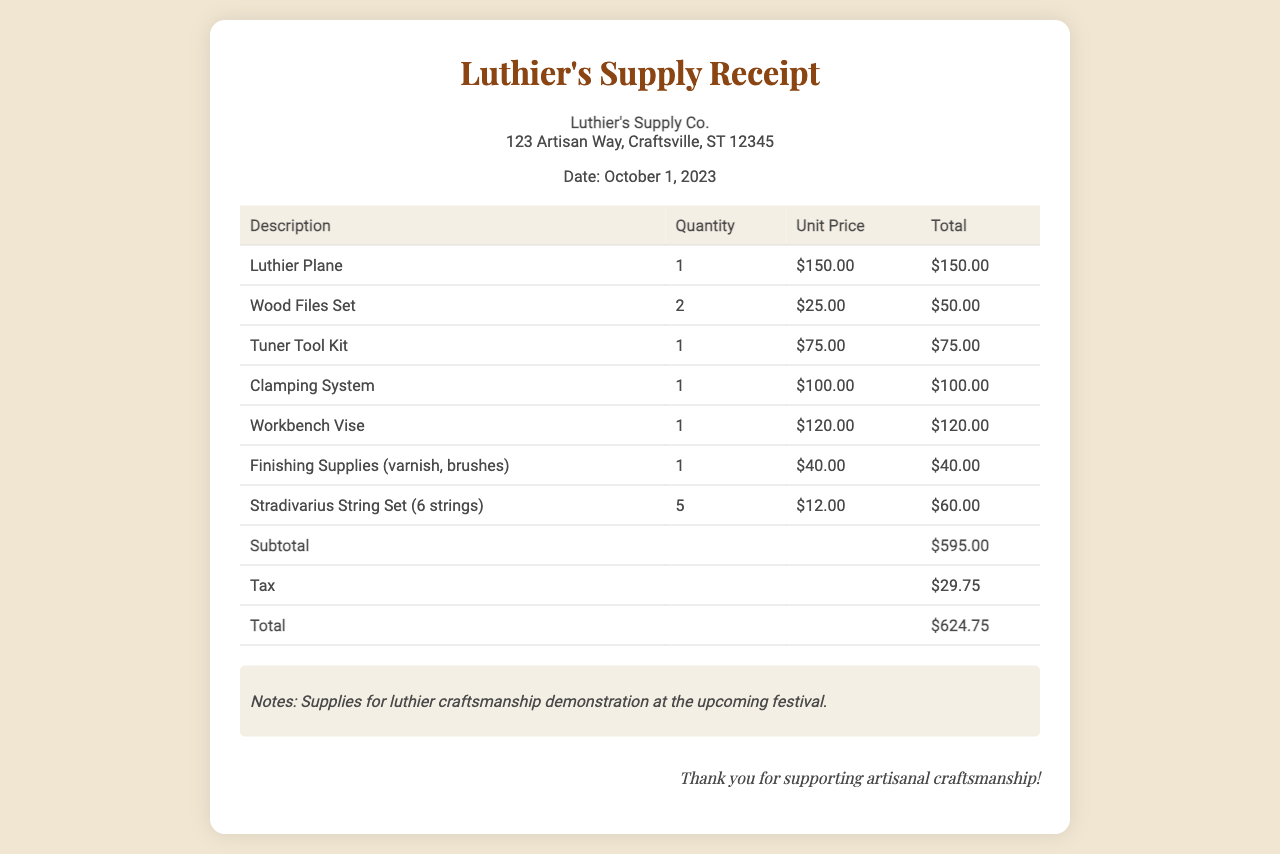What is the date of the receipt? The date listed on the receipt is October 1, 2023, which indicates when the supplies were purchased.
Answer: October 1, 2023 Who is the vendor? The vendor information in the document provides the name of the supplier of the tools, which is Luthier's Supply Co.
Answer: Luthier's Supply Co What is the total amount spent? The total amount is summarily calculated at the end of the receipt and includes subtotal and tax, which is $624.75.
Answer: $624.75 How many Stradivarius String Sets were purchased? The receipt details the quantity of each item bought, showing that 5 Stradivarius String Sets were acquired.
Answer: 5 What is the unit price of the clamping system? The unit price for the clamping system is detailed in the document, which amounts to $100.00.
Answer: $100.00 What category of items does the note refer to? The note on the receipt states its purpose, which is for the luthier craftsmanship demonstration at the upcoming festival.
Answer: Luthier craftsmanship demonstration How many different types of tools are listed? By counting the different items in the receipt's table, we find there are 7 unique tools and supplies documented.
Answer: 7 What tax amount is shown in the receipt? The tax is clearly stated in the receipt, providing the total tax amount of $29.75.
Answer: $29.75 